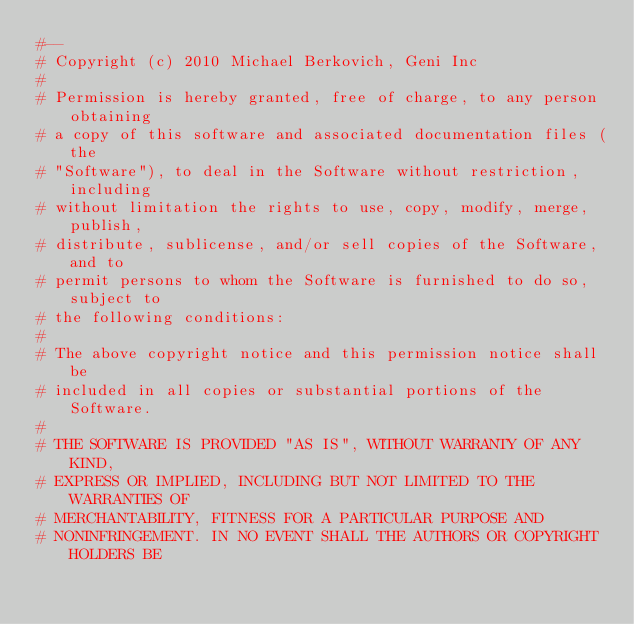Convert code to text. <code><loc_0><loc_0><loc_500><loc_500><_Ruby_>#--
# Copyright (c) 2010 Michael Berkovich, Geni Inc
#
# Permission is hereby granted, free of charge, to any person obtaining
# a copy of this software and associated documentation files (the
# "Software"), to deal in the Software without restriction, including
# without limitation the rights to use, copy, modify, merge, publish,
# distribute, sublicense, and/or sell copies of the Software, and to
# permit persons to whom the Software is furnished to do so, subject to
# the following conditions:
#
# The above copyright notice and this permission notice shall be
# included in all copies or substantial portions of the Software.
#
# THE SOFTWARE IS PROVIDED "AS IS", WITHOUT WARRANTY OF ANY KIND,
# EXPRESS OR IMPLIED, INCLUDING BUT NOT LIMITED TO THE WARRANTIES OF
# MERCHANTABILITY, FITNESS FOR A PARTICULAR PURPOSE AND
# NONINFRINGEMENT. IN NO EVENT SHALL THE AUTHORS OR COPYRIGHT HOLDERS BE</code> 